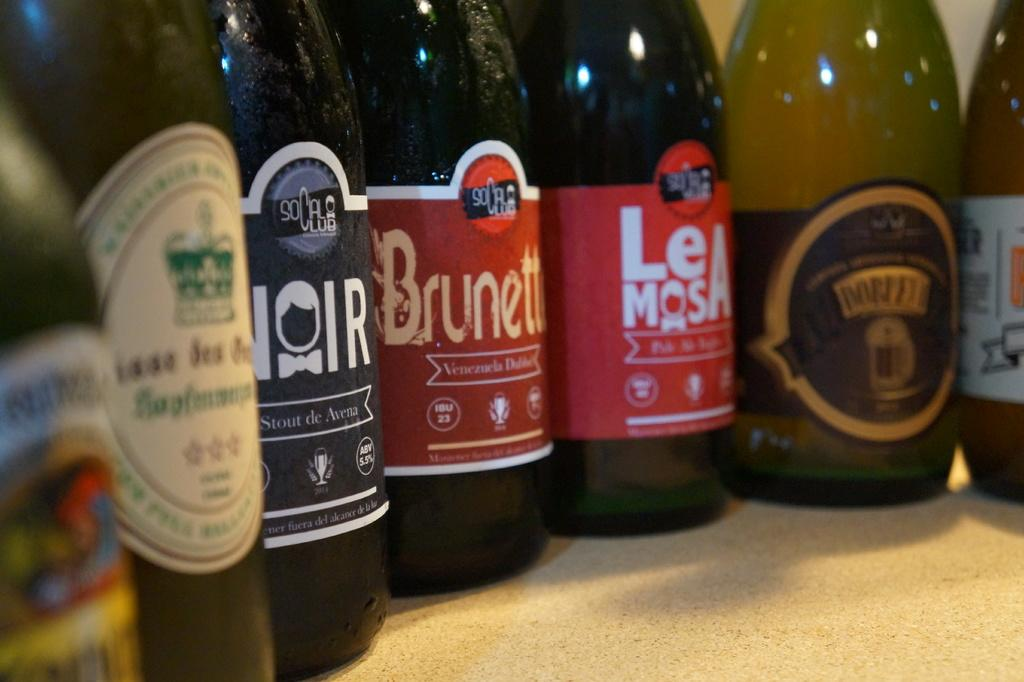<image>
Offer a succinct explanation of the picture presented. Bottled with one that says Brunette on it. 